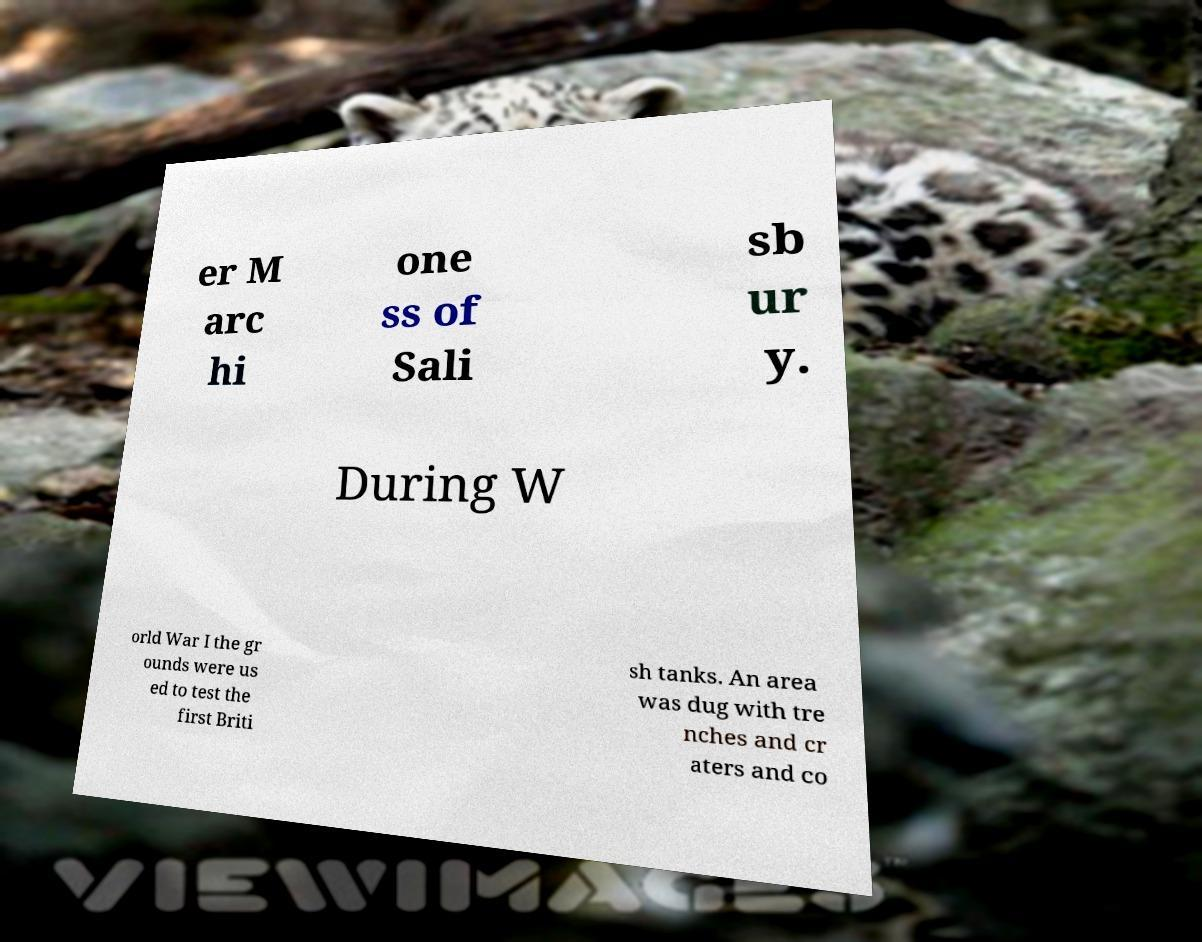What messages or text are displayed in this image? I need them in a readable, typed format. er M arc hi one ss of Sali sb ur y. During W orld War I the gr ounds were us ed to test the first Briti sh tanks. An area was dug with tre nches and cr aters and co 